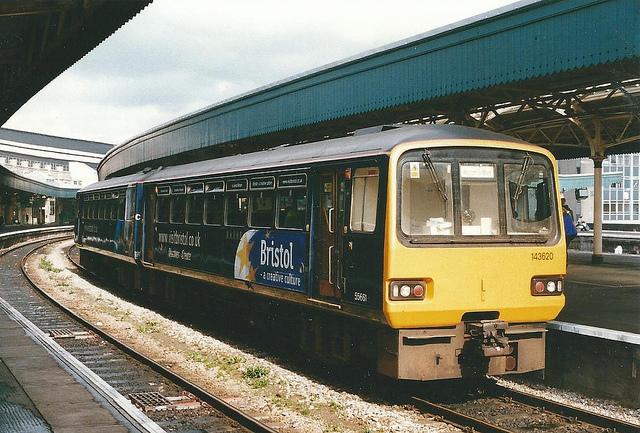How many train tracks are visible?
Short answer required. 2. Is this a freight train?
Quick response, please. No. How many seats can you see?
Concise answer only. 0. Can the driver be seen?
Write a very short answer. No. Is this an urban train station?
Be succinct. Yes. 